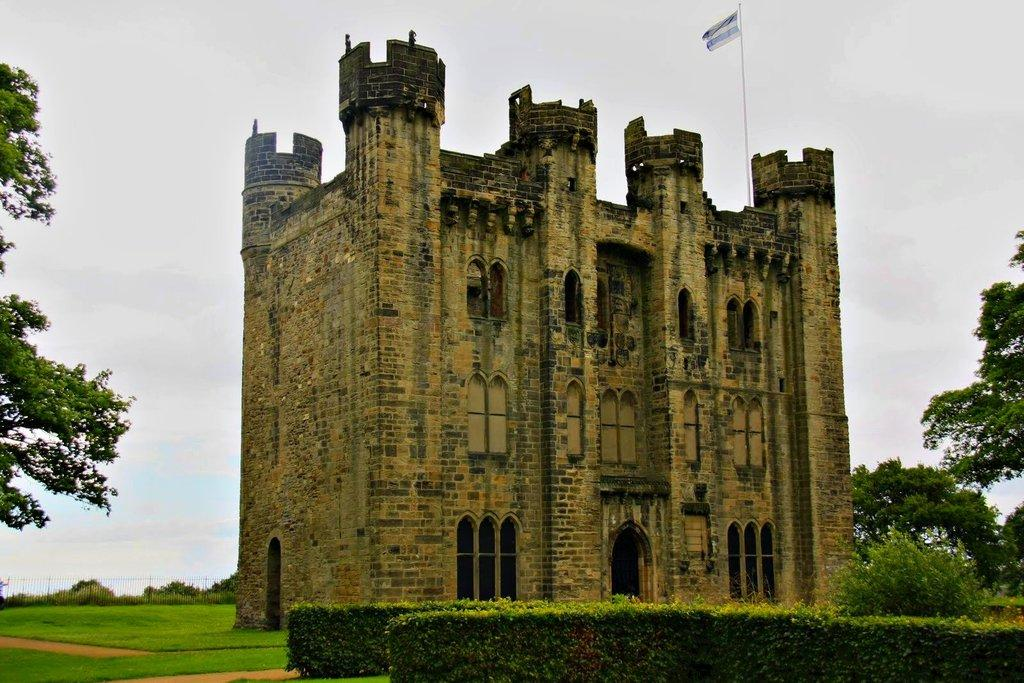What type of structure is visible in the image? There is a building in the image. What other natural elements can be seen in the image? There are plants, trees, and grass visible in the image. What is the purpose of the flag in the image? The flag in the image may represent a country, organization, or event. What type of barrier is present in the image? There is a fence in the image. What is visible in the background of the image? The sky is visible in the background of the image. Where is the lunchroom located in the image? There is no mention of a lunchroom in the image; it features a building, plants, a flag, trees, grass, a fence, and the sky. What type of crime is being committed in the image? There is no indication of any crime being committed in the image. 